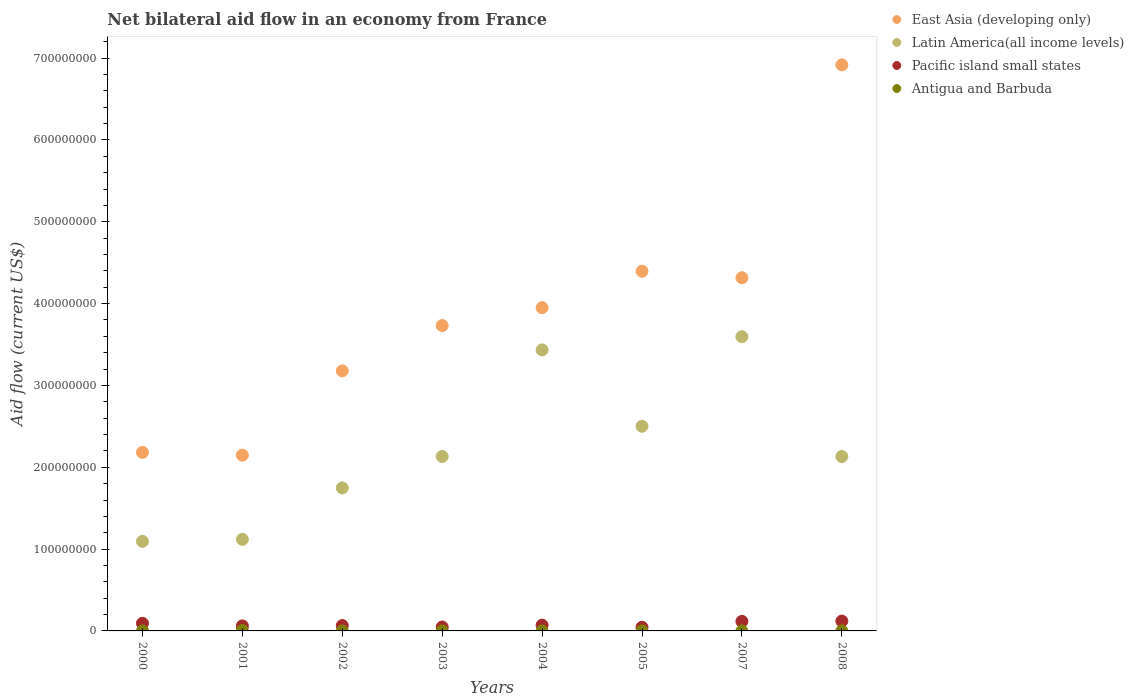Is the number of dotlines equal to the number of legend labels?
Offer a terse response. Yes. What is the net bilateral aid flow in Latin America(all income levels) in 2005?
Give a very brief answer. 2.50e+08. Across all years, what is the maximum net bilateral aid flow in East Asia (developing only)?
Offer a terse response. 6.92e+08. Across all years, what is the minimum net bilateral aid flow in Pacific island small states?
Provide a short and direct response. 4.45e+06. What is the total net bilateral aid flow in Antigua and Barbuda in the graph?
Your response must be concise. 7.00e+05. What is the difference between the net bilateral aid flow in Pacific island small states in 2001 and that in 2007?
Offer a terse response. -5.50e+06. What is the difference between the net bilateral aid flow in Pacific island small states in 2008 and the net bilateral aid flow in East Asia (developing only) in 2007?
Ensure brevity in your answer.  -4.20e+08. What is the average net bilateral aid flow in East Asia (developing only) per year?
Ensure brevity in your answer.  3.85e+08. In the year 2007, what is the difference between the net bilateral aid flow in Latin America(all income levels) and net bilateral aid flow in Antigua and Barbuda?
Provide a succinct answer. 3.60e+08. What is the ratio of the net bilateral aid flow in Pacific island small states in 2002 to that in 2008?
Provide a short and direct response. 0.54. What is the difference between the highest and the second highest net bilateral aid flow in Antigua and Barbuda?
Make the answer very short. 5.50e+05. What is the difference between the highest and the lowest net bilateral aid flow in Pacific island small states?
Provide a short and direct response. 7.58e+06. Is it the case that in every year, the sum of the net bilateral aid flow in Pacific island small states and net bilateral aid flow in Latin America(all income levels)  is greater than the sum of net bilateral aid flow in East Asia (developing only) and net bilateral aid flow in Antigua and Barbuda?
Keep it short and to the point. Yes. Is it the case that in every year, the sum of the net bilateral aid flow in Pacific island small states and net bilateral aid flow in East Asia (developing only)  is greater than the net bilateral aid flow in Latin America(all income levels)?
Offer a very short reply. Yes. Is the net bilateral aid flow in Antigua and Barbuda strictly greater than the net bilateral aid flow in Latin America(all income levels) over the years?
Keep it short and to the point. No. Is the net bilateral aid flow in Latin America(all income levels) strictly less than the net bilateral aid flow in East Asia (developing only) over the years?
Your answer should be very brief. Yes. What is the difference between two consecutive major ticks on the Y-axis?
Provide a short and direct response. 1.00e+08. Are the values on the major ticks of Y-axis written in scientific E-notation?
Ensure brevity in your answer.  No. Does the graph contain any zero values?
Provide a succinct answer. No. Where does the legend appear in the graph?
Your response must be concise. Top right. How are the legend labels stacked?
Your answer should be compact. Vertical. What is the title of the graph?
Give a very brief answer. Net bilateral aid flow in an economy from France. What is the Aid flow (current US$) in East Asia (developing only) in 2000?
Keep it short and to the point. 2.18e+08. What is the Aid flow (current US$) in Latin America(all income levels) in 2000?
Your answer should be very brief. 1.09e+08. What is the Aid flow (current US$) of Pacific island small states in 2000?
Your answer should be compact. 9.29e+06. What is the Aid flow (current US$) of East Asia (developing only) in 2001?
Provide a short and direct response. 2.15e+08. What is the Aid flow (current US$) in Latin America(all income levels) in 2001?
Your response must be concise. 1.12e+08. What is the Aid flow (current US$) in Pacific island small states in 2001?
Provide a succinct answer. 6.15e+06. What is the Aid flow (current US$) in Antigua and Barbuda in 2001?
Ensure brevity in your answer.  5.80e+05. What is the Aid flow (current US$) of East Asia (developing only) in 2002?
Give a very brief answer. 3.18e+08. What is the Aid flow (current US$) of Latin America(all income levels) in 2002?
Provide a succinct answer. 1.75e+08. What is the Aid flow (current US$) in Pacific island small states in 2002?
Provide a short and direct response. 6.55e+06. What is the Aid flow (current US$) of East Asia (developing only) in 2003?
Your answer should be compact. 3.73e+08. What is the Aid flow (current US$) of Latin America(all income levels) in 2003?
Your answer should be very brief. 2.13e+08. What is the Aid flow (current US$) of Pacific island small states in 2003?
Make the answer very short. 4.81e+06. What is the Aid flow (current US$) in Antigua and Barbuda in 2003?
Provide a short and direct response. 10000. What is the Aid flow (current US$) in East Asia (developing only) in 2004?
Offer a very short reply. 3.95e+08. What is the Aid flow (current US$) of Latin America(all income levels) in 2004?
Your answer should be very brief. 3.43e+08. What is the Aid flow (current US$) in Pacific island small states in 2004?
Ensure brevity in your answer.  7.02e+06. What is the Aid flow (current US$) of Antigua and Barbuda in 2004?
Keep it short and to the point. 2.00e+04. What is the Aid flow (current US$) of East Asia (developing only) in 2005?
Offer a very short reply. 4.40e+08. What is the Aid flow (current US$) of Latin America(all income levels) in 2005?
Offer a very short reply. 2.50e+08. What is the Aid flow (current US$) in Pacific island small states in 2005?
Ensure brevity in your answer.  4.45e+06. What is the Aid flow (current US$) of Antigua and Barbuda in 2005?
Make the answer very short. 3.00e+04. What is the Aid flow (current US$) in East Asia (developing only) in 2007?
Your answer should be compact. 4.32e+08. What is the Aid flow (current US$) in Latin America(all income levels) in 2007?
Keep it short and to the point. 3.60e+08. What is the Aid flow (current US$) in Pacific island small states in 2007?
Offer a terse response. 1.16e+07. What is the Aid flow (current US$) of Antigua and Barbuda in 2007?
Provide a succinct answer. 2.00e+04. What is the Aid flow (current US$) of East Asia (developing only) in 2008?
Provide a succinct answer. 6.92e+08. What is the Aid flow (current US$) of Latin America(all income levels) in 2008?
Keep it short and to the point. 2.13e+08. What is the Aid flow (current US$) in Pacific island small states in 2008?
Provide a short and direct response. 1.20e+07. Across all years, what is the maximum Aid flow (current US$) in East Asia (developing only)?
Your response must be concise. 6.92e+08. Across all years, what is the maximum Aid flow (current US$) of Latin America(all income levels)?
Ensure brevity in your answer.  3.60e+08. Across all years, what is the maximum Aid flow (current US$) in Pacific island small states?
Your answer should be compact. 1.20e+07. Across all years, what is the maximum Aid flow (current US$) of Antigua and Barbuda?
Ensure brevity in your answer.  5.80e+05. Across all years, what is the minimum Aid flow (current US$) in East Asia (developing only)?
Keep it short and to the point. 2.15e+08. Across all years, what is the minimum Aid flow (current US$) of Latin America(all income levels)?
Provide a short and direct response. 1.09e+08. Across all years, what is the minimum Aid flow (current US$) of Pacific island small states?
Ensure brevity in your answer.  4.45e+06. What is the total Aid flow (current US$) in East Asia (developing only) in the graph?
Your answer should be very brief. 3.08e+09. What is the total Aid flow (current US$) of Latin America(all income levels) in the graph?
Provide a succinct answer. 1.78e+09. What is the total Aid flow (current US$) of Pacific island small states in the graph?
Provide a succinct answer. 6.20e+07. What is the total Aid flow (current US$) of Antigua and Barbuda in the graph?
Offer a very short reply. 7.00e+05. What is the difference between the Aid flow (current US$) in East Asia (developing only) in 2000 and that in 2001?
Your answer should be compact. 3.42e+06. What is the difference between the Aid flow (current US$) of Latin America(all income levels) in 2000 and that in 2001?
Provide a succinct answer. -2.40e+06. What is the difference between the Aid flow (current US$) in Pacific island small states in 2000 and that in 2001?
Give a very brief answer. 3.14e+06. What is the difference between the Aid flow (current US$) of Antigua and Barbuda in 2000 and that in 2001?
Provide a succinct answer. -5.70e+05. What is the difference between the Aid flow (current US$) in East Asia (developing only) in 2000 and that in 2002?
Keep it short and to the point. -9.96e+07. What is the difference between the Aid flow (current US$) in Latin America(all income levels) in 2000 and that in 2002?
Your answer should be compact. -6.53e+07. What is the difference between the Aid flow (current US$) in Pacific island small states in 2000 and that in 2002?
Provide a succinct answer. 2.74e+06. What is the difference between the Aid flow (current US$) of East Asia (developing only) in 2000 and that in 2003?
Your answer should be compact. -1.55e+08. What is the difference between the Aid flow (current US$) of Latin America(all income levels) in 2000 and that in 2003?
Offer a very short reply. -1.04e+08. What is the difference between the Aid flow (current US$) of Pacific island small states in 2000 and that in 2003?
Offer a terse response. 4.48e+06. What is the difference between the Aid flow (current US$) of East Asia (developing only) in 2000 and that in 2004?
Keep it short and to the point. -1.77e+08. What is the difference between the Aid flow (current US$) in Latin America(all income levels) in 2000 and that in 2004?
Offer a very short reply. -2.34e+08. What is the difference between the Aid flow (current US$) in Pacific island small states in 2000 and that in 2004?
Make the answer very short. 2.27e+06. What is the difference between the Aid flow (current US$) in Antigua and Barbuda in 2000 and that in 2004?
Keep it short and to the point. -10000. What is the difference between the Aid flow (current US$) of East Asia (developing only) in 2000 and that in 2005?
Your answer should be very brief. -2.21e+08. What is the difference between the Aid flow (current US$) in Latin America(all income levels) in 2000 and that in 2005?
Offer a very short reply. -1.41e+08. What is the difference between the Aid flow (current US$) in Pacific island small states in 2000 and that in 2005?
Your answer should be very brief. 4.84e+06. What is the difference between the Aid flow (current US$) in Antigua and Barbuda in 2000 and that in 2005?
Make the answer very short. -2.00e+04. What is the difference between the Aid flow (current US$) of East Asia (developing only) in 2000 and that in 2007?
Provide a short and direct response. -2.13e+08. What is the difference between the Aid flow (current US$) in Latin America(all income levels) in 2000 and that in 2007?
Give a very brief answer. -2.50e+08. What is the difference between the Aid flow (current US$) in Pacific island small states in 2000 and that in 2007?
Your response must be concise. -2.36e+06. What is the difference between the Aid flow (current US$) of Antigua and Barbuda in 2000 and that in 2007?
Make the answer very short. -10000. What is the difference between the Aid flow (current US$) of East Asia (developing only) in 2000 and that in 2008?
Your response must be concise. -4.74e+08. What is the difference between the Aid flow (current US$) of Latin America(all income levels) in 2000 and that in 2008?
Provide a succinct answer. -1.04e+08. What is the difference between the Aid flow (current US$) in Pacific island small states in 2000 and that in 2008?
Ensure brevity in your answer.  -2.74e+06. What is the difference between the Aid flow (current US$) in Antigua and Barbuda in 2000 and that in 2008?
Make the answer very short. 0. What is the difference between the Aid flow (current US$) in East Asia (developing only) in 2001 and that in 2002?
Keep it short and to the point. -1.03e+08. What is the difference between the Aid flow (current US$) of Latin America(all income levels) in 2001 and that in 2002?
Ensure brevity in your answer.  -6.29e+07. What is the difference between the Aid flow (current US$) of Pacific island small states in 2001 and that in 2002?
Ensure brevity in your answer.  -4.00e+05. What is the difference between the Aid flow (current US$) of Antigua and Barbuda in 2001 and that in 2002?
Offer a terse response. 5.60e+05. What is the difference between the Aid flow (current US$) in East Asia (developing only) in 2001 and that in 2003?
Ensure brevity in your answer.  -1.58e+08. What is the difference between the Aid flow (current US$) of Latin America(all income levels) in 2001 and that in 2003?
Offer a terse response. -1.01e+08. What is the difference between the Aid flow (current US$) in Pacific island small states in 2001 and that in 2003?
Provide a short and direct response. 1.34e+06. What is the difference between the Aid flow (current US$) in Antigua and Barbuda in 2001 and that in 2003?
Make the answer very short. 5.70e+05. What is the difference between the Aid flow (current US$) in East Asia (developing only) in 2001 and that in 2004?
Give a very brief answer. -1.80e+08. What is the difference between the Aid flow (current US$) in Latin America(all income levels) in 2001 and that in 2004?
Offer a terse response. -2.32e+08. What is the difference between the Aid flow (current US$) in Pacific island small states in 2001 and that in 2004?
Keep it short and to the point. -8.70e+05. What is the difference between the Aid flow (current US$) of Antigua and Barbuda in 2001 and that in 2004?
Your answer should be very brief. 5.60e+05. What is the difference between the Aid flow (current US$) in East Asia (developing only) in 2001 and that in 2005?
Provide a short and direct response. -2.25e+08. What is the difference between the Aid flow (current US$) of Latin America(all income levels) in 2001 and that in 2005?
Provide a succinct answer. -1.38e+08. What is the difference between the Aid flow (current US$) of Pacific island small states in 2001 and that in 2005?
Your answer should be very brief. 1.70e+06. What is the difference between the Aid flow (current US$) of East Asia (developing only) in 2001 and that in 2007?
Make the answer very short. -2.17e+08. What is the difference between the Aid flow (current US$) in Latin America(all income levels) in 2001 and that in 2007?
Offer a very short reply. -2.48e+08. What is the difference between the Aid flow (current US$) in Pacific island small states in 2001 and that in 2007?
Provide a succinct answer. -5.50e+06. What is the difference between the Aid flow (current US$) of Antigua and Barbuda in 2001 and that in 2007?
Make the answer very short. 5.60e+05. What is the difference between the Aid flow (current US$) in East Asia (developing only) in 2001 and that in 2008?
Provide a short and direct response. -4.77e+08. What is the difference between the Aid flow (current US$) in Latin America(all income levels) in 2001 and that in 2008?
Offer a terse response. -1.01e+08. What is the difference between the Aid flow (current US$) of Pacific island small states in 2001 and that in 2008?
Give a very brief answer. -5.88e+06. What is the difference between the Aid flow (current US$) of Antigua and Barbuda in 2001 and that in 2008?
Provide a short and direct response. 5.70e+05. What is the difference between the Aid flow (current US$) of East Asia (developing only) in 2002 and that in 2003?
Offer a very short reply. -5.54e+07. What is the difference between the Aid flow (current US$) of Latin America(all income levels) in 2002 and that in 2003?
Provide a short and direct response. -3.85e+07. What is the difference between the Aid flow (current US$) of Pacific island small states in 2002 and that in 2003?
Your response must be concise. 1.74e+06. What is the difference between the Aid flow (current US$) in Antigua and Barbuda in 2002 and that in 2003?
Provide a short and direct response. 10000. What is the difference between the Aid flow (current US$) in East Asia (developing only) in 2002 and that in 2004?
Make the answer very short. -7.72e+07. What is the difference between the Aid flow (current US$) in Latin America(all income levels) in 2002 and that in 2004?
Offer a terse response. -1.69e+08. What is the difference between the Aid flow (current US$) of Pacific island small states in 2002 and that in 2004?
Offer a very short reply. -4.70e+05. What is the difference between the Aid flow (current US$) of East Asia (developing only) in 2002 and that in 2005?
Provide a succinct answer. -1.22e+08. What is the difference between the Aid flow (current US$) in Latin America(all income levels) in 2002 and that in 2005?
Offer a terse response. -7.54e+07. What is the difference between the Aid flow (current US$) of Pacific island small states in 2002 and that in 2005?
Offer a terse response. 2.10e+06. What is the difference between the Aid flow (current US$) in Antigua and Barbuda in 2002 and that in 2005?
Provide a short and direct response. -10000. What is the difference between the Aid flow (current US$) of East Asia (developing only) in 2002 and that in 2007?
Your answer should be compact. -1.14e+08. What is the difference between the Aid flow (current US$) of Latin America(all income levels) in 2002 and that in 2007?
Offer a very short reply. -1.85e+08. What is the difference between the Aid flow (current US$) of Pacific island small states in 2002 and that in 2007?
Offer a terse response. -5.10e+06. What is the difference between the Aid flow (current US$) in Antigua and Barbuda in 2002 and that in 2007?
Offer a terse response. 0. What is the difference between the Aid flow (current US$) of East Asia (developing only) in 2002 and that in 2008?
Make the answer very short. -3.74e+08. What is the difference between the Aid flow (current US$) in Latin America(all income levels) in 2002 and that in 2008?
Make the answer very short. -3.84e+07. What is the difference between the Aid flow (current US$) of Pacific island small states in 2002 and that in 2008?
Your answer should be compact. -5.48e+06. What is the difference between the Aid flow (current US$) in East Asia (developing only) in 2003 and that in 2004?
Your response must be concise. -2.18e+07. What is the difference between the Aid flow (current US$) of Latin America(all income levels) in 2003 and that in 2004?
Give a very brief answer. -1.30e+08. What is the difference between the Aid flow (current US$) of Pacific island small states in 2003 and that in 2004?
Make the answer very short. -2.21e+06. What is the difference between the Aid flow (current US$) of East Asia (developing only) in 2003 and that in 2005?
Your answer should be compact. -6.64e+07. What is the difference between the Aid flow (current US$) in Latin America(all income levels) in 2003 and that in 2005?
Offer a very short reply. -3.69e+07. What is the difference between the Aid flow (current US$) in Pacific island small states in 2003 and that in 2005?
Your answer should be very brief. 3.60e+05. What is the difference between the Aid flow (current US$) of Antigua and Barbuda in 2003 and that in 2005?
Offer a very short reply. -2.00e+04. What is the difference between the Aid flow (current US$) of East Asia (developing only) in 2003 and that in 2007?
Provide a succinct answer. -5.84e+07. What is the difference between the Aid flow (current US$) of Latin America(all income levels) in 2003 and that in 2007?
Make the answer very short. -1.46e+08. What is the difference between the Aid flow (current US$) in Pacific island small states in 2003 and that in 2007?
Keep it short and to the point. -6.84e+06. What is the difference between the Aid flow (current US$) of East Asia (developing only) in 2003 and that in 2008?
Offer a terse response. -3.19e+08. What is the difference between the Aid flow (current US$) in Pacific island small states in 2003 and that in 2008?
Your response must be concise. -7.22e+06. What is the difference between the Aid flow (current US$) in East Asia (developing only) in 2004 and that in 2005?
Give a very brief answer. -4.46e+07. What is the difference between the Aid flow (current US$) of Latin America(all income levels) in 2004 and that in 2005?
Make the answer very short. 9.33e+07. What is the difference between the Aid flow (current US$) of Pacific island small states in 2004 and that in 2005?
Your answer should be very brief. 2.57e+06. What is the difference between the Aid flow (current US$) of East Asia (developing only) in 2004 and that in 2007?
Your answer should be very brief. -3.66e+07. What is the difference between the Aid flow (current US$) in Latin America(all income levels) in 2004 and that in 2007?
Provide a short and direct response. -1.62e+07. What is the difference between the Aid flow (current US$) of Pacific island small states in 2004 and that in 2007?
Give a very brief answer. -4.63e+06. What is the difference between the Aid flow (current US$) of Antigua and Barbuda in 2004 and that in 2007?
Make the answer very short. 0. What is the difference between the Aid flow (current US$) in East Asia (developing only) in 2004 and that in 2008?
Provide a succinct answer. -2.97e+08. What is the difference between the Aid flow (current US$) in Latin America(all income levels) in 2004 and that in 2008?
Make the answer very short. 1.30e+08. What is the difference between the Aid flow (current US$) in Pacific island small states in 2004 and that in 2008?
Give a very brief answer. -5.01e+06. What is the difference between the Aid flow (current US$) in Antigua and Barbuda in 2004 and that in 2008?
Provide a short and direct response. 10000. What is the difference between the Aid flow (current US$) in East Asia (developing only) in 2005 and that in 2007?
Give a very brief answer. 7.94e+06. What is the difference between the Aid flow (current US$) of Latin America(all income levels) in 2005 and that in 2007?
Your response must be concise. -1.09e+08. What is the difference between the Aid flow (current US$) in Pacific island small states in 2005 and that in 2007?
Your answer should be compact. -7.20e+06. What is the difference between the Aid flow (current US$) of Antigua and Barbuda in 2005 and that in 2007?
Give a very brief answer. 10000. What is the difference between the Aid flow (current US$) of East Asia (developing only) in 2005 and that in 2008?
Make the answer very short. -2.52e+08. What is the difference between the Aid flow (current US$) in Latin America(all income levels) in 2005 and that in 2008?
Provide a succinct answer. 3.70e+07. What is the difference between the Aid flow (current US$) in Pacific island small states in 2005 and that in 2008?
Your response must be concise. -7.58e+06. What is the difference between the Aid flow (current US$) in Antigua and Barbuda in 2005 and that in 2008?
Give a very brief answer. 2.00e+04. What is the difference between the Aid flow (current US$) in East Asia (developing only) in 2007 and that in 2008?
Offer a very short reply. -2.60e+08. What is the difference between the Aid flow (current US$) in Latin America(all income levels) in 2007 and that in 2008?
Ensure brevity in your answer.  1.46e+08. What is the difference between the Aid flow (current US$) of Pacific island small states in 2007 and that in 2008?
Ensure brevity in your answer.  -3.80e+05. What is the difference between the Aid flow (current US$) in East Asia (developing only) in 2000 and the Aid flow (current US$) in Latin America(all income levels) in 2001?
Give a very brief answer. 1.06e+08. What is the difference between the Aid flow (current US$) of East Asia (developing only) in 2000 and the Aid flow (current US$) of Pacific island small states in 2001?
Provide a succinct answer. 2.12e+08. What is the difference between the Aid flow (current US$) in East Asia (developing only) in 2000 and the Aid flow (current US$) in Antigua and Barbuda in 2001?
Make the answer very short. 2.18e+08. What is the difference between the Aid flow (current US$) of Latin America(all income levels) in 2000 and the Aid flow (current US$) of Pacific island small states in 2001?
Your answer should be very brief. 1.03e+08. What is the difference between the Aid flow (current US$) of Latin America(all income levels) in 2000 and the Aid flow (current US$) of Antigua and Barbuda in 2001?
Provide a short and direct response. 1.09e+08. What is the difference between the Aid flow (current US$) of Pacific island small states in 2000 and the Aid flow (current US$) of Antigua and Barbuda in 2001?
Your response must be concise. 8.71e+06. What is the difference between the Aid flow (current US$) in East Asia (developing only) in 2000 and the Aid flow (current US$) in Latin America(all income levels) in 2002?
Offer a very short reply. 4.35e+07. What is the difference between the Aid flow (current US$) of East Asia (developing only) in 2000 and the Aid flow (current US$) of Pacific island small states in 2002?
Your answer should be compact. 2.12e+08. What is the difference between the Aid flow (current US$) in East Asia (developing only) in 2000 and the Aid flow (current US$) in Antigua and Barbuda in 2002?
Offer a very short reply. 2.18e+08. What is the difference between the Aid flow (current US$) of Latin America(all income levels) in 2000 and the Aid flow (current US$) of Pacific island small states in 2002?
Provide a short and direct response. 1.03e+08. What is the difference between the Aid flow (current US$) of Latin America(all income levels) in 2000 and the Aid flow (current US$) of Antigua and Barbuda in 2002?
Your response must be concise. 1.09e+08. What is the difference between the Aid flow (current US$) in Pacific island small states in 2000 and the Aid flow (current US$) in Antigua and Barbuda in 2002?
Provide a short and direct response. 9.27e+06. What is the difference between the Aid flow (current US$) of East Asia (developing only) in 2000 and the Aid flow (current US$) of Latin America(all income levels) in 2003?
Provide a succinct answer. 5.00e+06. What is the difference between the Aid flow (current US$) in East Asia (developing only) in 2000 and the Aid flow (current US$) in Pacific island small states in 2003?
Keep it short and to the point. 2.13e+08. What is the difference between the Aid flow (current US$) in East Asia (developing only) in 2000 and the Aid flow (current US$) in Antigua and Barbuda in 2003?
Provide a short and direct response. 2.18e+08. What is the difference between the Aid flow (current US$) in Latin America(all income levels) in 2000 and the Aid flow (current US$) in Pacific island small states in 2003?
Your answer should be compact. 1.05e+08. What is the difference between the Aid flow (current US$) in Latin America(all income levels) in 2000 and the Aid flow (current US$) in Antigua and Barbuda in 2003?
Offer a terse response. 1.09e+08. What is the difference between the Aid flow (current US$) of Pacific island small states in 2000 and the Aid flow (current US$) of Antigua and Barbuda in 2003?
Your answer should be compact. 9.28e+06. What is the difference between the Aid flow (current US$) of East Asia (developing only) in 2000 and the Aid flow (current US$) of Latin America(all income levels) in 2004?
Provide a succinct answer. -1.25e+08. What is the difference between the Aid flow (current US$) of East Asia (developing only) in 2000 and the Aid flow (current US$) of Pacific island small states in 2004?
Your response must be concise. 2.11e+08. What is the difference between the Aid flow (current US$) in East Asia (developing only) in 2000 and the Aid flow (current US$) in Antigua and Barbuda in 2004?
Keep it short and to the point. 2.18e+08. What is the difference between the Aid flow (current US$) in Latin America(all income levels) in 2000 and the Aid flow (current US$) in Pacific island small states in 2004?
Keep it short and to the point. 1.02e+08. What is the difference between the Aid flow (current US$) of Latin America(all income levels) in 2000 and the Aid flow (current US$) of Antigua and Barbuda in 2004?
Ensure brevity in your answer.  1.09e+08. What is the difference between the Aid flow (current US$) of Pacific island small states in 2000 and the Aid flow (current US$) of Antigua and Barbuda in 2004?
Give a very brief answer. 9.27e+06. What is the difference between the Aid flow (current US$) in East Asia (developing only) in 2000 and the Aid flow (current US$) in Latin America(all income levels) in 2005?
Your answer should be compact. -3.19e+07. What is the difference between the Aid flow (current US$) of East Asia (developing only) in 2000 and the Aid flow (current US$) of Pacific island small states in 2005?
Offer a terse response. 2.14e+08. What is the difference between the Aid flow (current US$) in East Asia (developing only) in 2000 and the Aid flow (current US$) in Antigua and Barbuda in 2005?
Provide a short and direct response. 2.18e+08. What is the difference between the Aid flow (current US$) of Latin America(all income levels) in 2000 and the Aid flow (current US$) of Pacific island small states in 2005?
Your answer should be very brief. 1.05e+08. What is the difference between the Aid flow (current US$) of Latin America(all income levels) in 2000 and the Aid flow (current US$) of Antigua and Barbuda in 2005?
Offer a terse response. 1.09e+08. What is the difference between the Aid flow (current US$) of Pacific island small states in 2000 and the Aid flow (current US$) of Antigua and Barbuda in 2005?
Your answer should be compact. 9.26e+06. What is the difference between the Aid flow (current US$) of East Asia (developing only) in 2000 and the Aid flow (current US$) of Latin America(all income levels) in 2007?
Your answer should be compact. -1.41e+08. What is the difference between the Aid flow (current US$) of East Asia (developing only) in 2000 and the Aid flow (current US$) of Pacific island small states in 2007?
Your answer should be compact. 2.07e+08. What is the difference between the Aid flow (current US$) of East Asia (developing only) in 2000 and the Aid flow (current US$) of Antigua and Barbuda in 2007?
Ensure brevity in your answer.  2.18e+08. What is the difference between the Aid flow (current US$) of Latin America(all income levels) in 2000 and the Aid flow (current US$) of Pacific island small states in 2007?
Your answer should be very brief. 9.78e+07. What is the difference between the Aid flow (current US$) of Latin America(all income levels) in 2000 and the Aid flow (current US$) of Antigua and Barbuda in 2007?
Your answer should be very brief. 1.09e+08. What is the difference between the Aid flow (current US$) of Pacific island small states in 2000 and the Aid flow (current US$) of Antigua and Barbuda in 2007?
Provide a succinct answer. 9.27e+06. What is the difference between the Aid flow (current US$) in East Asia (developing only) in 2000 and the Aid flow (current US$) in Latin America(all income levels) in 2008?
Your response must be concise. 5.04e+06. What is the difference between the Aid flow (current US$) of East Asia (developing only) in 2000 and the Aid flow (current US$) of Pacific island small states in 2008?
Make the answer very short. 2.06e+08. What is the difference between the Aid flow (current US$) in East Asia (developing only) in 2000 and the Aid flow (current US$) in Antigua and Barbuda in 2008?
Make the answer very short. 2.18e+08. What is the difference between the Aid flow (current US$) of Latin America(all income levels) in 2000 and the Aid flow (current US$) of Pacific island small states in 2008?
Your response must be concise. 9.74e+07. What is the difference between the Aid flow (current US$) of Latin America(all income levels) in 2000 and the Aid flow (current US$) of Antigua and Barbuda in 2008?
Provide a short and direct response. 1.09e+08. What is the difference between the Aid flow (current US$) of Pacific island small states in 2000 and the Aid flow (current US$) of Antigua and Barbuda in 2008?
Your answer should be very brief. 9.28e+06. What is the difference between the Aid flow (current US$) in East Asia (developing only) in 2001 and the Aid flow (current US$) in Latin America(all income levels) in 2002?
Ensure brevity in your answer.  4.00e+07. What is the difference between the Aid flow (current US$) of East Asia (developing only) in 2001 and the Aid flow (current US$) of Pacific island small states in 2002?
Offer a very short reply. 2.08e+08. What is the difference between the Aid flow (current US$) of East Asia (developing only) in 2001 and the Aid flow (current US$) of Antigua and Barbuda in 2002?
Offer a terse response. 2.15e+08. What is the difference between the Aid flow (current US$) of Latin America(all income levels) in 2001 and the Aid flow (current US$) of Pacific island small states in 2002?
Offer a terse response. 1.05e+08. What is the difference between the Aid flow (current US$) of Latin America(all income levels) in 2001 and the Aid flow (current US$) of Antigua and Barbuda in 2002?
Provide a succinct answer. 1.12e+08. What is the difference between the Aid flow (current US$) of Pacific island small states in 2001 and the Aid flow (current US$) of Antigua and Barbuda in 2002?
Your answer should be compact. 6.13e+06. What is the difference between the Aid flow (current US$) of East Asia (developing only) in 2001 and the Aid flow (current US$) of Latin America(all income levels) in 2003?
Keep it short and to the point. 1.58e+06. What is the difference between the Aid flow (current US$) of East Asia (developing only) in 2001 and the Aid flow (current US$) of Pacific island small states in 2003?
Make the answer very short. 2.10e+08. What is the difference between the Aid flow (current US$) in East Asia (developing only) in 2001 and the Aid flow (current US$) in Antigua and Barbuda in 2003?
Your answer should be very brief. 2.15e+08. What is the difference between the Aid flow (current US$) of Latin America(all income levels) in 2001 and the Aid flow (current US$) of Pacific island small states in 2003?
Provide a short and direct response. 1.07e+08. What is the difference between the Aid flow (current US$) in Latin America(all income levels) in 2001 and the Aid flow (current US$) in Antigua and Barbuda in 2003?
Offer a very short reply. 1.12e+08. What is the difference between the Aid flow (current US$) in Pacific island small states in 2001 and the Aid flow (current US$) in Antigua and Barbuda in 2003?
Provide a succinct answer. 6.14e+06. What is the difference between the Aid flow (current US$) in East Asia (developing only) in 2001 and the Aid flow (current US$) in Latin America(all income levels) in 2004?
Offer a very short reply. -1.29e+08. What is the difference between the Aid flow (current US$) of East Asia (developing only) in 2001 and the Aid flow (current US$) of Pacific island small states in 2004?
Offer a terse response. 2.08e+08. What is the difference between the Aid flow (current US$) in East Asia (developing only) in 2001 and the Aid flow (current US$) in Antigua and Barbuda in 2004?
Provide a short and direct response. 2.15e+08. What is the difference between the Aid flow (current US$) of Latin America(all income levels) in 2001 and the Aid flow (current US$) of Pacific island small states in 2004?
Provide a short and direct response. 1.05e+08. What is the difference between the Aid flow (current US$) of Latin America(all income levels) in 2001 and the Aid flow (current US$) of Antigua and Barbuda in 2004?
Provide a short and direct response. 1.12e+08. What is the difference between the Aid flow (current US$) in Pacific island small states in 2001 and the Aid flow (current US$) in Antigua and Barbuda in 2004?
Your answer should be compact. 6.13e+06. What is the difference between the Aid flow (current US$) of East Asia (developing only) in 2001 and the Aid flow (current US$) of Latin America(all income levels) in 2005?
Keep it short and to the point. -3.53e+07. What is the difference between the Aid flow (current US$) of East Asia (developing only) in 2001 and the Aid flow (current US$) of Pacific island small states in 2005?
Your answer should be compact. 2.10e+08. What is the difference between the Aid flow (current US$) of East Asia (developing only) in 2001 and the Aid flow (current US$) of Antigua and Barbuda in 2005?
Your answer should be compact. 2.15e+08. What is the difference between the Aid flow (current US$) in Latin America(all income levels) in 2001 and the Aid flow (current US$) in Pacific island small states in 2005?
Provide a succinct answer. 1.07e+08. What is the difference between the Aid flow (current US$) of Latin America(all income levels) in 2001 and the Aid flow (current US$) of Antigua and Barbuda in 2005?
Make the answer very short. 1.12e+08. What is the difference between the Aid flow (current US$) in Pacific island small states in 2001 and the Aid flow (current US$) in Antigua and Barbuda in 2005?
Offer a terse response. 6.12e+06. What is the difference between the Aid flow (current US$) in East Asia (developing only) in 2001 and the Aid flow (current US$) in Latin America(all income levels) in 2007?
Keep it short and to the point. -1.45e+08. What is the difference between the Aid flow (current US$) in East Asia (developing only) in 2001 and the Aid flow (current US$) in Pacific island small states in 2007?
Make the answer very short. 2.03e+08. What is the difference between the Aid flow (current US$) of East Asia (developing only) in 2001 and the Aid flow (current US$) of Antigua and Barbuda in 2007?
Your response must be concise. 2.15e+08. What is the difference between the Aid flow (current US$) of Latin America(all income levels) in 2001 and the Aid flow (current US$) of Pacific island small states in 2007?
Your response must be concise. 1.00e+08. What is the difference between the Aid flow (current US$) in Latin America(all income levels) in 2001 and the Aid flow (current US$) in Antigua and Barbuda in 2007?
Offer a terse response. 1.12e+08. What is the difference between the Aid flow (current US$) in Pacific island small states in 2001 and the Aid flow (current US$) in Antigua and Barbuda in 2007?
Ensure brevity in your answer.  6.13e+06. What is the difference between the Aid flow (current US$) of East Asia (developing only) in 2001 and the Aid flow (current US$) of Latin America(all income levels) in 2008?
Make the answer very short. 1.62e+06. What is the difference between the Aid flow (current US$) of East Asia (developing only) in 2001 and the Aid flow (current US$) of Pacific island small states in 2008?
Your answer should be very brief. 2.03e+08. What is the difference between the Aid flow (current US$) of East Asia (developing only) in 2001 and the Aid flow (current US$) of Antigua and Barbuda in 2008?
Your answer should be very brief. 2.15e+08. What is the difference between the Aid flow (current US$) in Latin America(all income levels) in 2001 and the Aid flow (current US$) in Pacific island small states in 2008?
Make the answer very short. 9.98e+07. What is the difference between the Aid flow (current US$) in Latin America(all income levels) in 2001 and the Aid flow (current US$) in Antigua and Barbuda in 2008?
Your answer should be compact. 1.12e+08. What is the difference between the Aid flow (current US$) of Pacific island small states in 2001 and the Aid flow (current US$) of Antigua and Barbuda in 2008?
Your answer should be compact. 6.14e+06. What is the difference between the Aid flow (current US$) in East Asia (developing only) in 2002 and the Aid flow (current US$) in Latin America(all income levels) in 2003?
Make the answer very short. 1.05e+08. What is the difference between the Aid flow (current US$) of East Asia (developing only) in 2002 and the Aid flow (current US$) of Pacific island small states in 2003?
Keep it short and to the point. 3.13e+08. What is the difference between the Aid flow (current US$) of East Asia (developing only) in 2002 and the Aid flow (current US$) of Antigua and Barbuda in 2003?
Provide a succinct answer. 3.18e+08. What is the difference between the Aid flow (current US$) of Latin America(all income levels) in 2002 and the Aid flow (current US$) of Pacific island small states in 2003?
Keep it short and to the point. 1.70e+08. What is the difference between the Aid flow (current US$) in Latin America(all income levels) in 2002 and the Aid flow (current US$) in Antigua and Barbuda in 2003?
Your response must be concise. 1.75e+08. What is the difference between the Aid flow (current US$) of Pacific island small states in 2002 and the Aid flow (current US$) of Antigua and Barbuda in 2003?
Your answer should be very brief. 6.54e+06. What is the difference between the Aid flow (current US$) of East Asia (developing only) in 2002 and the Aid flow (current US$) of Latin America(all income levels) in 2004?
Offer a terse response. -2.56e+07. What is the difference between the Aid flow (current US$) of East Asia (developing only) in 2002 and the Aid flow (current US$) of Pacific island small states in 2004?
Your answer should be very brief. 3.11e+08. What is the difference between the Aid flow (current US$) in East Asia (developing only) in 2002 and the Aid flow (current US$) in Antigua and Barbuda in 2004?
Keep it short and to the point. 3.18e+08. What is the difference between the Aid flow (current US$) in Latin America(all income levels) in 2002 and the Aid flow (current US$) in Pacific island small states in 2004?
Provide a short and direct response. 1.68e+08. What is the difference between the Aid flow (current US$) in Latin America(all income levels) in 2002 and the Aid flow (current US$) in Antigua and Barbuda in 2004?
Your response must be concise. 1.75e+08. What is the difference between the Aid flow (current US$) in Pacific island small states in 2002 and the Aid flow (current US$) in Antigua and Barbuda in 2004?
Give a very brief answer. 6.53e+06. What is the difference between the Aid flow (current US$) in East Asia (developing only) in 2002 and the Aid flow (current US$) in Latin America(all income levels) in 2005?
Ensure brevity in your answer.  6.77e+07. What is the difference between the Aid flow (current US$) in East Asia (developing only) in 2002 and the Aid flow (current US$) in Pacific island small states in 2005?
Provide a short and direct response. 3.13e+08. What is the difference between the Aid flow (current US$) in East Asia (developing only) in 2002 and the Aid flow (current US$) in Antigua and Barbuda in 2005?
Give a very brief answer. 3.18e+08. What is the difference between the Aid flow (current US$) of Latin America(all income levels) in 2002 and the Aid flow (current US$) of Pacific island small states in 2005?
Your answer should be very brief. 1.70e+08. What is the difference between the Aid flow (current US$) of Latin America(all income levels) in 2002 and the Aid flow (current US$) of Antigua and Barbuda in 2005?
Provide a succinct answer. 1.75e+08. What is the difference between the Aid flow (current US$) in Pacific island small states in 2002 and the Aid flow (current US$) in Antigua and Barbuda in 2005?
Offer a terse response. 6.52e+06. What is the difference between the Aid flow (current US$) of East Asia (developing only) in 2002 and the Aid flow (current US$) of Latin America(all income levels) in 2007?
Your response must be concise. -4.17e+07. What is the difference between the Aid flow (current US$) of East Asia (developing only) in 2002 and the Aid flow (current US$) of Pacific island small states in 2007?
Provide a short and direct response. 3.06e+08. What is the difference between the Aid flow (current US$) in East Asia (developing only) in 2002 and the Aid flow (current US$) in Antigua and Barbuda in 2007?
Your response must be concise. 3.18e+08. What is the difference between the Aid flow (current US$) in Latin America(all income levels) in 2002 and the Aid flow (current US$) in Pacific island small states in 2007?
Your answer should be very brief. 1.63e+08. What is the difference between the Aid flow (current US$) in Latin America(all income levels) in 2002 and the Aid flow (current US$) in Antigua and Barbuda in 2007?
Your response must be concise. 1.75e+08. What is the difference between the Aid flow (current US$) of Pacific island small states in 2002 and the Aid flow (current US$) of Antigua and Barbuda in 2007?
Make the answer very short. 6.53e+06. What is the difference between the Aid flow (current US$) of East Asia (developing only) in 2002 and the Aid flow (current US$) of Latin America(all income levels) in 2008?
Your answer should be very brief. 1.05e+08. What is the difference between the Aid flow (current US$) in East Asia (developing only) in 2002 and the Aid flow (current US$) in Pacific island small states in 2008?
Offer a terse response. 3.06e+08. What is the difference between the Aid flow (current US$) of East Asia (developing only) in 2002 and the Aid flow (current US$) of Antigua and Barbuda in 2008?
Offer a terse response. 3.18e+08. What is the difference between the Aid flow (current US$) in Latin America(all income levels) in 2002 and the Aid flow (current US$) in Pacific island small states in 2008?
Ensure brevity in your answer.  1.63e+08. What is the difference between the Aid flow (current US$) of Latin America(all income levels) in 2002 and the Aid flow (current US$) of Antigua and Barbuda in 2008?
Keep it short and to the point. 1.75e+08. What is the difference between the Aid flow (current US$) of Pacific island small states in 2002 and the Aid flow (current US$) of Antigua and Barbuda in 2008?
Your answer should be very brief. 6.54e+06. What is the difference between the Aid flow (current US$) of East Asia (developing only) in 2003 and the Aid flow (current US$) of Latin America(all income levels) in 2004?
Your response must be concise. 2.98e+07. What is the difference between the Aid flow (current US$) in East Asia (developing only) in 2003 and the Aid flow (current US$) in Pacific island small states in 2004?
Your answer should be compact. 3.66e+08. What is the difference between the Aid flow (current US$) of East Asia (developing only) in 2003 and the Aid flow (current US$) of Antigua and Barbuda in 2004?
Your answer should be very brief. 3.73e+08. What is the difference between the Aid flow (current US$) of Latin America(all income levels) in 2003 and the Aid flow (current US$) of Pacific island small states in 2004?
Keep it short and to the point. 2.06e+08. What is the difference between the Aid flow (current US$) in Latin America(all income levels) in 2003 and the Aid flow (current US$) in Antigua and Barbuda in 2004?
Offer a very short reply. 2.13e+08. What is the difference between the Aid flow (current US$) in Pacific island small states in 2003 and the Aid flow (current US$) in Antigua and Barbuda in 2004?
Provide a succinct answer. 4.79e+06. What is the difference between the Aid flow (current US$) in East Asia (developing only) in 2003 and the Aid flow (current US$) in Latin America(all income levels) in 2005?
Give a very brief answer. 1.23e+08. What is the difference between the Aid flow (current US$) of East Asia (developing only) in 2003 and the Aid flow (current US$) of Pacific island small states in 2005?
Provide a short and direct response. 3.69e+08. What is the difference between the Aid flow (current US$) in East Asia (developing only) in 2003 and the Aid flow (current US$) in Antigua and Barbuda in 2005?
Give a very brief answer. 3.73e+08. What is the difference between the Aid flow (current US$) in Latin America(all income levels) in 2003 and the Aid flow (current US$) in Pacific island small states in 2005?
Provide a succinct answer. 2.09e+08. What is the difference between the Aid flow (current US$) in Latin America(all income levels) in 2003 and the Aid flow (current US$) in Antigua and Barbuda in 2005?
Provide a succinct answer. 2.13e+08. What is the difference between the Aid flow (current US$) of Pacific island small states in 2003 and the Aid flow (current US$) of Antigua and Barbuda in 2005?
Your answer should be compact. 4.78e+06. What is the difference between the Aid flow (current US$) of East Asia (developing only) in 2003 and the Aid flow (current US$) of Latin America(all income levels) in 2007?
Keep it short and to the point. 1.37e+07. What is the difference between the Aid flow (current US$) of East Asia (developing only) in 2003 and the Aid flow (current US$) of Pacific island small states in 2007?
Provide a succinct answer. 3.62e+08. What is the difference between the Aid flow (current US$) of East Asia (developing only) in 2003 and the Aid flow (current US$) of Antigua and Barbuda in 2007?
Your answer should be very brief. 3.73e+08. What is the difference between the Aid flow (current US$) in Latin America(all income levels) in 2003 and the Aid flow (current US$) in Pacific island small states in 2007?
Your answer should be compact. 2.02e+08. What is the difference between the Aid flow (current US$) of Latin America(all income levels) in 2003 and the Aid flow (current US$) of Antigua and Barbuda in 2007?
Provide a succinct answer. 2.13e+08. What is the difference between the Aid flow (current US$) in Pacific island small states in 2003 and the Aid flow (current US$) in Antigua and Barbuda in 2007?
Keep it short and to the point. 4.79e+06. What is the difference between the Aid flow (current US$) in East Asia (developing only) in 2003 and the Aid flow (current US$) in Latin America(all income levels) in 2008?
Your answer should be compact. 1.60e+08. What is the difference between the Aid flow (current US$) of East Asia (developing only) in 2003 and the Aid flow (current US$) of Pacific island small states in 2008?
Your answer should be very brief. 3.61e+08. What is the difference between the Aid flow (current US$) of East Asia (developing only) in 2003 and the Aid flow (current US$) of Antigua and Barbuda in 2008?
Keep it short and to the point. 3.73e+08. What is the difference between the Aid flow (current US$) of Latin America(all income levels) in 2003 and the Aid flow (current US$) of Pacific island small states in 2008?
Ensure brevity in your answer.  2.01e+08. What is the difference between the Aid flow (current US$) of Latin America(all income levels) in 2003 and the Aid flow (current US$) of Antigua and Barbuda in 2008?
Offer a terse response. 2.13e+08. What is the difference between the Aid flow (current US$) in Pacific island small states in 2003 and the Aid flow (current US$) in Antigua and Barbuda in 2008?
Keep it short and to the point. 4.80e+06. What is the difference between the Aid flow (current US$) in East Asia (developing only) in 2004 and the Aid flow (current US$) in Latin America(all income levels) in 2005?
Your response must be concise. 1.45e+08. What is the difference between the Aid flow (current US$) in East Asia (developing only) in 2004 and the Aid flow (current US$) in Pacific island small states in 2005?
Give a very brief answer. 3.91e+08. What is the difference between the Aid flow (current US$) in East Asia (developing only) in 2004 and the Aid flow (current US$) in Antigua and Barbuda in 2005?
Provide a short and direct response. 3.95e+08. What is the difference between the Aid flow (current US$) of Latin America(all income levels) in 2004 and the Aid flow (current US$) of Pacific island small states in 2005?
Ensure brevity in your answer.  3.39e+08. What is the difference between the Aid flow (current US$) of Latin America(all income levels) in 2004 and the Aid flow (current US$) of Antigua and Barbuda in 2005?
Your response must be concise. 3.43e+08. What is the difference between the Aid flow (current US$) in Pacific island small states in 2004 and the Aid flow (current US$) in Antigua and Barbuda in 2005?
Provide a short and direct response. 6.99e+06. What is the difference between the Aid flow (current US$) in East Asia (developing only) in 2004 and the Aid flow (current US$) in Latin America(all income levels) in 2007?
Your answer should be compact. 3.55e+07. What is the difference between the Aid flow (current US$) of East Asia (developing only) in 2004 and the Aid flow (current US$) of Pacific island small states in 2007?
Your answer should be compact. 3.83e+08. What is the difference between the Aid flow (current US$) in East Asia (developing only) in 2004 and the Aid flow (current US$) in Antigua and Barbuda in 2007?
Offer a terse response. 3.95e+08. What is the difference between the Aid flow (current US$) of Latin America(all income levels) in 2004 and the Aid flow (current US$) of Pacific island small states in 2007?
Provide a succinct answer. 3.32e+08. What is the difference between the Aid flow (current US$) in Latin America(all income levels) in 2004 and the Aid flow (current US$) in Antigua and Barbuda in 2007?
Offer a terse response. 3.43e+08. What is the difference between the Aid flow (current US$) of East Asia (developing only) in 2004 and the Aid flow (current US$) of Latin America(all income levels) in 2008?
Ensure brevity in your answer.  1.82e+08. What is the difference between the Aid flow (current US$) of East Asia (developing only) in 2004 and the Aid flow (current US$) of Pacific island small states in 2008?
Provide a succinct answer. 3.83e+08. What is the difference between the Aid flow (current US$) of East Asia (developing only) in 2004 and the Aid flow (current US$) of Antigua and Barbuda in 2008?
Give a very brief answer. 3.95e+08. What is the difference between the Aid flow (current US$) of Latin America(all income levels) in 2004 and the Aid flow (current US$) of Pacific island small states in 2008?
Your answer should be compact. 3.31e+08. What is the difference between the Aid flow (current US$) in Latin America(all income levels) in 2004 and the Aid flow (current US$) in Antigua and Barbuda in 2008?
Provide a succinct answer. 3.43e+08. What is the difference between the Aid flow (current US$) of Pacific island small states in 2004 and the Aid flow (current US$) of Antigua and Barbuda in 2008?
Keep it short and to the point. 7.01e+06. What is the difference between the Aid flow (current US$) of East Asia (developing only) in 2005 and the Aid flow (current US$) of Latin America(all income levels) in 2007?
Give a very brief answer. 8.00e+07. What is the difference between the Aid flow (current US$) of East Asia (developing only) in 2005 and the Aid flow (current US$) of Pacific island small states in 2007?
Give a very brief answer. 4.28e+08. What is the difference between the Aid flow (current US$) in East Asia (developing only) in 2005 and the Aid flow (current US$) in Antigua and Barbuda in 2007?
Provide a succinct answer. 4.40e+08. What is the difference between the Aid flow (current US$) of Latin America(all income levels) in 2005 and the Aid flow (current US$) of Pacific island small states in 2007?
Your answer should be very brief. 2.38e+08. What is the difference between the Aid flow (current US$) of Latin America(all income levels) in 2005 and the Aid flow (current US$) of Antigua and Barbuda in 2007?
Provide a short and direct response. 2.50e+08. What is the difference between the Aid flow (current US$) in Pacific island small states in 2005 and the Aid flow (current US$) in Antigua and Barbuda in 2007?
Offer a terse response. 4.43e+06. What is the difference between the Aid flow (current US$) in East Asia (developing only) in 2005 and the Aid flow (current US$) in Latin America(all income levels) in 2008?
Offer a very short reply. 2.26e+08. What is the difference between the Aid flow (current US$) of East Asia (developing only) in 2005 and the Aid flow (current US$) of Pacific island small states in 2008?
Your answer should be compact. 4.28e+08. What is the difference between the Aid flow (current US$) in East Asia (developing only) in 2005 and the Aid flow (current US$) in Antigua and Barbuda in 2008?
Your answer should be very brief. 4.40e+08. What is the difference between the Aid flow (current US$) of Latin America(all income levels) in 2005 and the Aid flow (current US$) of Pacific island small states in 2008?
Give a very brief answer. 2.38e+08. What is the difference between the Aid flow (current US$) of Latin America(all income levels) in 2005 and the Aid flow (current US$) of Antigua and Barbuda in 2008?
Keep it short and to the point. 2.50e+08. What is the difference between the Aid flow (current US$) in Pacific island small states in 2005 and the Aid flow (current US$) in Antigua and Barbuda in 2008?
Give a very brief answer. 4.44e+06. What is the difference between the Aid flow (current US$) in East Asia (developing only) in 2007 and the Aid flow (current US$) in Latin America(all income levels) in 2008?
Your response must be concise. 2.18e+08. What is the difference between the Aid flow (current US$) of East Asia (developing only) in 2007 and the Aid flow (current US$) of Pacific island small states in 2008?
Offer a very short reply. 4.20e+08. What is the difference between the Aid flow (current US$) of East Asia (developing only) in 2007 and the Aid flow (current US$) of Antigua and Barbuda in 2008?
Keep it short and to the point. 4.32e+08. What is the difference between the Aid flow (current US$) in Latin America(all income levels) in 2007 and the Aid flow (current US$) in Pacific island small states in 2008?
Keep it short and to the point. 3.48e+08. What is the difference between the Aid flow (current US$) in Latin America(all income levels) in 2007 and the Aid flow (current US$) in Antigua and Barbuda in 2008?
Your answer should be very brief. 3.60e+08. What is the difference between the Aid flow (current US$) in Pacific island small states in 2007 and the Aid flow (current US$) in Antigua and Barbuda in 2008?
Keep it short and to the point. 1.16e+07. What is the average Aid flow (current US$) in East Asia (developing only) per year?
Your answer should be very brief. 3.85e+08. What is the average Aid flow (current US$) of Latin America(all income levels) per year?
Keep it short and to the point. 2.22e+08. What is the average Aid flow (current US$) in Pacific island small states per year?
Make the answer very short. 7.74e+06. What is the average Aid flow (current US$) in Antigua and Barbuda per year?
Your response must be concise. 8.75e+04. In the year 2000, what is the difference between the Aid flow (current US$) in East Asia (developing only) and Aid flow (current US$) in Latin America(all income levels)?
Give a very brief answer. 1.09e+08. In the year 2000, what is the difference between the Aid flow (current US$) in East Asia (developing only) and Aid flow (current US$) in Pacific island small states?
Give a very brief answer. 2.09e+08. In the year 2000, what is the difference between the Aid flow (current US$) of East Asia (developing only) and Aid flow (current US$) of Antigua and Barbuda?
Offer a terse response. 2.18e+08. In the year 2000, what is the difference between the Aid flow (current US$) of Latin America(all income levels) and Aid flow (current US$) of Pacific island small states?
Your answer should be very brief. 1.00e+08. In the year 2000, what is the difference between the Aid flow (current US$) in Latin America(all income levels) and Aid flow (current US$) in Antigua and Barbuda?
Ensure brevity in your answer.  1.09e+08. In the year 2000, what is the difference between the Aid flow (current US$) in Pacific island small states and Aid flow (current US$) in Antigua and Barbuda?
Your answer should be very brief. 9.28e+06. In the year 2001, what is the difference between the Aid flow (current US$) in East Asia (developing only) and Aid flow (current US$) in Latin America(all income levels)?
Offer a very short reply. 1.03e+08. In the year 2001, what is the difference between the Aid flow (current US$) in East Asia (developing only) and Aid flow (current US$) in Pacific island small states?
Offer a terse response. 2.09e+08. In the year 2001, what is the difference between the Aid flow (current US$) of East Asia (developing only) and Aid flow (current US$) of Antigua and Barbuda?
Provide a short and direct response. 2.14e+08. In the year 2001, what is the difference between the Aid flow (current US$) of Latin America(all income levels) and Aid flow (current US$) of Pacific island small states?
Your answer should be compact. 1.06e+08. In the year 2001, what is the difference between the Aid flow (current US$) of Latin America(all income levels) and Aid flow (current US$) of Antigua and Barbuda?
Your response must be concise. 1.11e+08. In the year 2001, what is the difference between the Aid flow (current US$) in Pacific island small states and Aid flow (current US$) in Antigua and Barbuda?
Provide a succinct answer. 5.57e+06. In the year 2002, what is the difference between the Aid flow (current US$) of East Asia (developing only) and Aid flow (current US$) of Latin America(all income levels)?
Ensure brevity in your answer.  1.43e+08. In the year 2002, what is the difference between the Aid flow (current US$) in East Asia (developing only) and Aid flow (current US$) in Pacific island small states?
Give a very brief answer. 3.11e+08. In the year 2002, what is the difference between the Aid flow (current US$) in East Asia (developing only) and Aid flow (current US$) in Antigua and Barbuda?
Offer a terse response. 3.18e+08. In the year 2002, what is the difference between the Aid flow (current US$) in Latin America(all income levels) and Aid flow (current US$) in Pacific island small states?
Your answer should be very brief. 1.68e+08. In the year 2002, what is the difference between the Aid flow (current US$) in Latin America(all income levels) and Aid flow (current US$) in Antigua and Barbuda?
Your answer should be very brief. 1.75e+08. In the year 2002, what is the difference between the Aid flow (current US$) of Pacific island small states and Aid flow (current US$) of Antigua and Barbuda?
Provide a succinct answer. 6.53e+06. In the year 2003, what is the difference between the Aid flow (current US$) in East Asia (developing only) and Aid flow (current US$) in Latin America(all income levels)?
Make the answer very short. 1.60e+08. In the year 2003, what is the difference between the Aid flow (current US$) in East Asia (developing only) and Aid flow (current US$) in Pacific island small states?
Give a very brief answer. 3.68e+08. In the year 2003, what is the difference between the Aid flow (current US$) of East Asia (developing only) and Aid flow (current US$) of Antigua and Barbuda?
Keep it short and to the point. 3.73e+08. In the year 2003, what is the difference between the Aid flow (current US$) of Latin America(all income levels) and Aid flow (current US$) of Pacific island small states?
Your answer should be very brief. 2.08e+08. In the year 2003, what is the difference between the Aid flow (current US$) of Latin America(all income levels) and Aid flow (current US$) of Antigua and Barbuda?
Give a very brief answer. 2.13e+08. In the year 2003, what is the difference between the Aid flow (current US$) of Pacific island small states and Aid flow (current US$) of Antigua and Barbuda?
Provide a succinct answer. 4.80e+06. In the year 2004, what is the difference between the Aid flow (current US$) of East Asia (developing only) and Aid flow (current US$) of Latin America(all income levels)?
Your answer should be compact. 5.16e+07. In the year 2004, what is the difference between the Aid flow (current US$) in East Asia (developing only) and Aid flow (current US$) in Pacific island small states?
Give a very brief answer. 3.88e+08. In the year 2004, what is the difference between the Aid flow (current US$) of East Asia (developing only) and Aid flow (current US$) of Antigua and Barbuda?
Offer a very short reply. 3.95e+08. In the year 2004, what is the difference between the Aid flow (current US$) of Latin America(all income levels) and Aid flow (current US$) of Pacific island small states?
Offer a terse response. 3.36e+08. In the year 2004, what is the difference between the Aid flow (current US$) in Latin America(all income levels) and Aid flow (current US$) in Antigua and Barbuda?
Provide a short and direct response. 3.43e+08. In the year 2004, what is the difference between the Aid flow (current US$) of Pacific island small states and Aid flow (current US$) of Antigua and Barbuda?
Your response must be concise. 7.00e+06. In the year 2005, what is the difference between the Aid flow (current US$) in East Asia (developing only) and Aid flow (current US$) in Latin America(all income levels)?
Provide a short and direct response. 1.89e+08. In the year 2005, what is the difference between the Aid flow (current US$) of East Asia (developing only) and Aid flow (current US$) of Pacific island small states?
Provide a short and direct response. 4.35e+08. In the year 2005, what is the difference between the Aid flow (current US$) in East Asia (developing only) and Aid flow (current US$) in Antigua and Barbuda?
Make the answer very short. 4.40e+08. In the year 2005, what is the difference between the Aid flow (current US$) in Latin America(all income levels) and Aid flow (current US$) in Pacific island small states?
Ensure brevity in your answer.  2.46e+08. In the year 2005, what is the difference between the Aid flow (current US$) of Latin America(all income levels) and Aid flow (current US$) of Antigua and Barbuda?
Your answer should be compact. 2.50e+08. In the year 2005, what is the difference between the Aid flow (current US$) of Pacific island small states and Aid flow (current US$) of Antigua and Barbuda?
Provide a succinct answer. 4.42e+06. In the year 2007, what is the difference between the Aid flow (current US$) of East Asia (developing only) and Aid flow (current US$) of Latin America(all income levels)?
Ensure brevity in your answer.  7.21e+07. In the year 2007, what is the difference between the Aid flow (current US$) of East Asia (developing only) and Aid flow (current US$) of Pacific island small states?
Provide a succinct answer. 4.20e+08. In the year 2007, what is the difference between the Aid flow (current US$) in East Asia (developing only) and Aid flow (current US$) in Antigua and Barbuda?
Give a very brief answer. 4.32e+08. In the year 2007, what is the difference between the Aid flow (current US$) in Latin America(all income levels) and Aid flow (current US$) in Pacific island small states?
Your answer should be very brief. 3.48e+08. In the year 2007, what is the difference between the Aid flow (current US$) in Latin America(all income levels) and Aid flow (current US$) in Antigua and Barbuda?
Your response must be concise. 3.60e+08. In the year 2007, what is the difference between the Aid flow (current US$) in Pacific island small states and Aid flow (current US$) in Antigua and Barbuda?
Offer a terse response. 1.16e+07. In the year 2008, what is the difference between the Aid flow (current US$) of East Asia (developing only) and Aid flow (current US$) of Latin America(all income levels)?
Make the answer very short. 4.79e+08. In the year 2008, what is the difference between the Aid flow (current US$) of East Asia (developing only) and Aid flow (current US$) of Pacific island small states?
Ensure brevity in your answer.  6.80e+08. In the year 2008, what is the difference between the Aid flow (current US$) of East Asia (developing only) and Aid flow (current US$) of Antigua and Barbuda?
Provide a succinct answer. 6.92e+08. In the year 2008, what is the difference between the Aid flow (current US$) in Latin America(all income levels) and Aid flow (current US$) in Pacific island small states?
Your answer should be compact. 2.01e+08. In the year 2008, what is the difference between the Aid flow (current US$) in Latin America(all income levels) and Aid flow (current US$) in Antigua and Barbuda?
Give a very brief answer. 2.13e+08. In the year 2008, what is the difference between the Aid flow (current US$) in Pacific island small states and Aid flow (current US$) in Antigua and Barbuda?
Your answer should be very brief. 1.20e+07. What is the ratio of the Aid flow (current US$) in East Asia (developing only) in 2000 to that in 2001?
Provide a succinct answer. 1.02. What is the ratio of the Aid flow (current US$) of Latin America(all income levels) in 2000 to that in 2001?
Your response must be concise. 0.98. What is the ratio of the Aid flow (current US$) in Pacific island small states in 2000 to that in 2001?
Your answer should be compact. 1.51. What is the ratio of the Aid flow (current US$) of Antigua and Barbuda in 2000 to that in 2001?
Offer a terse response. 0.02. What is the ratio of the Aid flow (current US$) of East Asia (developing only) in 2000 to that in 2002?
Offer a very short reply. 0.69. What is the ratio of the Aid flow (current US$) of Latin America(all income levels) in 2000 to that in 2002?
Your answer should be compact. 0.63. What is the ratio of the Aid flow (current US$) in Pacific island small states in 2000 to that in 2002?
Your answer should be compact. 1.42. What is the ratio of the Aid flow (current US$) of East Asia (developing only) in 2000 to that in 2003?
Ensure brevity in your answer.  0.58. What is the ratio of the Aid flow (current US$) in Latin America(all income levels) in 2000 to that in 2003?
Your response must be concise. 0.51. What is the ratio of the Aid flow (current US$) of Pacific island small states in 2000 to that in 2003?
Your answer should be compact. 1.93. What is the ratio of the Aid flow (current US$) of East Asia (developing only) in 2000 to that in 2004?
Provide a succinct answer. 0.55. What is the ratio of the Aid flow (current US$) in Latin America(all income levels) in 2000 to that in 2004?
Your answer should be very brief. 0.32. What is the ratio of the Aid flow (current US$) in Pacific island small states in 2000 to that in 2004?
Ensure brevity in your answer.  1.32. What is the ratio of the Aid flow (current US$) in East Asia (developing only) in 2000 to that in 2005?
Keep it short and to the point. 0.5. What is the ratio of the Aid flow (current US$) of Latin America(all income levels) in 2000 to that in 2005?
Provide a succinct answer. 0.44. What is the ratio of the Aid flow (current US$) in Pacific island small states in 2000 to that in 2005?
Your answer should be very brief. 2.09. What is the ratio of the Aid flow (current US$) in Antigua and Barbuda in 2000 to that in 2005?
Keep it short and to the point. 0.33. What is the ratio of the Aid flow (current US$) of East Asia (developing only) in 2000 to that in 2007?
Your answer should be compact. 0.51. What is the ratio of the Aid flow (current US$) of Latin America(all income levels) in 2000 to that in 2007?
Your answer should be compact. 0.3. What is the ratio of the Aid flow (current US$) in Pacific island small states in 2000 to that in 2007?
Your response must be concise. 0.8. What is the ratio of the Aid flow (current US$) of Antigua and Barbuda in 2000 to that in 2007?
Your answer should be compact. 0.5. What is the ratio of the Aid flow (current US$) in East Asia (developing only) in 2000 to that in 2008?
Keep it short and to the point. 0.32. What is the ratio of the Aid flow (current US$) of Latin America(all income levels) in 2000 to that in 2008?
Your answer should be very brief. 0.51. What is the ratio of the Aid flow (current US$) in Pacific island small states in 2000 to that in 2008?
Provide a succinct answer. 0.77. What is the ratio of the Aid flow (current US$) in Antigua and Barbuda in 2000 to that in 2008?
Offer a terse response. 1. What is the ratio of the Aid flow (current US$) in East Asia (developing only) in 2001 to that in 2002?
Ensure brevity in your answer.  0.68. What is the ratio of the Aid flow (current US$) in Latin America(all income levels) in 2001 to that in 2002?
Your answer should be very brief. 0.64. What is the ratio of the Aid flow (current US$) in Pacific island small states in 2001 to that in 2002?
Your response must be concise. 0.94. What is the ratio of the Aid flow (current US$) in East Asia (developing only) in 2001 to that in 2003?
Ensure brevity in your answer.  0.58. What is the ratio of the Aid flow (current US$) in Latin America(all income levels) in 2001 to that in 2003?
Give a very brief answer. 0.52. What is the ratio of the Aid flow (current US$) in Pacific island small states in 2001 to that in 2003?
Your answer should be compact. 1.28. What is the ratio of the Aid flow (current US$) in Antigua and Barbuda in 2001 to that in 2003?
Your answer should be compact. 58. What is the ratio of the Aid flow (current US$) of East Asia (developing only) in 2001 to that in 2004?
Make the answer very short. 0.54. What is the ratio of the Aid flow (current US$) in Latin America(all income levels) in 2001 to that in 2004?
Offer a very short reply. 0.33. What is the ratio of the Aid flow (current US$) in Pacific island small states in 2001 to that in 2004?
Provide a succinct answer. 0.88. What is the ratio of the Aid flow (current US$) in Antigua and Barbuda in 2001 to that in 2004?
Your answer should be compact. 29. What is the ratio of the Aid flow (current US$) in East Asia (developing only) in 2001 to that in 2005?
Ensure brevity in your answer.  0.49. What is the ratio of the Aid flow (current US$) of Latin America(all income levels) in 2001 to that in 2005?
Keep it short and to the point. 0.45. What is the ratio of the Aid flow (current US$) of Pacific island small states in 2001 to that in 2005?
Provide a short and direct response. 1.38. What is the ratio of the Aid flow (current US$) in Antigua and Barbuda in 2001 to that in 2005?
Provide a succinct answer. 19.33. What is the ratio of the Aid flow (current US$) of East Asia (developing only) in 2001 to that in 2007?
Keep it short and to the point. 0.5. What is the ratio of the Aid flow (current US$) in Latin America(all income levels) in 2001 to that in 2007?
Provide a short and direct response. 0.31. What is the ratio of the Aid flow (current US$) of Pacific island small states in 2001 to that in 2007?
Your response must be concise. 0.53. What is the ratio of the Aid flow (current US$) in East Asia (developing only) in 2001 to that in 2008?
Provide a short and direct response. 0.31. What is the ratio of the Aid flow (current US$) of Latin America(all income levels) in 2001 to that in 2008?
Offer a very short reply. 0.52. What is the ratio of the Aid flow (current US$) of Pacific island small states in 2001 to that in 2008?
Offer a terse response. 0.51. What is the ratio of the Aid flow (current US$) of East Asia (developing only) in 2002 to that in 2003?
Your response must be concise. 0.85. What is the ratio of the Aid flow (current US$) of Latin America(all income levels) in 2002 to that in 2003?
Your answer should be very brief. 0.82. What is the ratio of the Aid flow (current US$) in Pacific island small states in 2002 to that in 2003?
Provide a succinct answer. 1.36. What is the ratio of the Aid flow (current US$) of East Asia (developing only) in 2002 to that in 2004?
Your answer should be very brief. 0.8. What is the ratio of the Aid flow (current US$) of Latin America(all income levels) in 2002 to that in 2004?
Make the answer very short. 0.51. What is the ratio of the Aid flow (current US$) of Pacific island small states in 2002 to that in 2004?
Provide a succinct answer. 0.93. What is the ratio of the Aid flow (current US$) of East Asia (developing only) in 2002 to that in 2005?
Provide a short and direct response. 0.72. What is the ratio of the Aid flow (current US$) in Latin America(all income levels) in 2002 to that in 2005?
Make the answer very short. 0.7. What is the ratio of the Aid flow (current US$) of Pacific island small states in 2002 to that in 2005?
Your response must be concise. 1.47. What is the ratio of the Aid flow (current US$) in Antigua and Barbuda in 2002 to that in 2005?
Keep it short and to the point. 0.67. What is the ratio of the Aid flow (current US$) in East Asia (developing only) in 2002 to that in 2007?
Keep it short and to the point. 0.74. What is the ratio of the Aid flow (current US$) of Latin America(all income levels) in 2002 to that in 2007?
Your response must be concise. 0.49. What is the ratio of the Aid flow (current US$) in Pacific island small states in 2002 to that in 2007?
Make the answer very short. 0.56. What is the ratio of the Aid flow (current US$) in East Asia (developing only) in 2002 to that in 2008?
Your answer should be compact. 0.46. What is the ratio of the Aid flow (current US$) in Latin America(all income levels) in 2002 to that in 2008?
Keep it short and to the point. 0.82. What is the ratio of the Aid flow (current US$) in Pacific island small states in 2002 to that in 2008?
Your answer should be compact. 0.54. What is the ratio of the Aid flow (current US$) of East Asia (developing only) in 2003 to that in 2004?
Provide a succinct answer. 0.94. What is the ratio of the Aid flow (current US$) in Latin America(all income levels) in 2003 to that in 2004?
Your answer should be very brief. 0.62. What is the ratio of the Aid flow (current US$) of Pacific island small states in 2003 to that in 2004?
Provide a short and direct response. 0.69. What is the ratio of the Aid flow (current US$) in Antigua and Barbuda in 2003 to that in 2004?
Your answer should be compact. 0.5. What is the ratio of the Aid flow (current US$) of East Asia (developing only) in 2003 to that in 2005?
Your response must be concise. 0.85. What is the ratio of the Aid flow (current US$) in Latin America(all income levels) in 2003 to that in 2005?
Make the answer very short. 0.85. What is the ratio of the Aid flow (current US$) of Pacific island small states in 2003 to that in 2005?
Make the answer very short. 1.08. What is the ratio of the Aid flow (current US$) of East Asia (developing only) in 2003 to that in 2007?
Your answer should be very brief. 0.86. What is the ratio of the Aid flow (current US$) of Latin America(all income levels) in 2003 to that in 2007?
Your answer should be very brief. 0.59. What is the ratio of the Aid flow (current US$) in Pacific island small states in 2003 to that in 2007?
Ensure brevity in your answer.  0.41. What is the ratio of the Aid flow (current US$) of Antigua and Barbuda in 2003 to that in 2007?
Offer a very short reply. 0.5. What is the ratio of the Aid flow (current US$) in East Asia (developing only) in 2003 to that in 2008?
Your response must be concise. 0.54. What is the ratio of the Aid flow (current US$) of Pacific island small states in 2003 to that in 2008?
Your answer should be very brief. 0.4. What is the ratio of the Aid flow (current US$) in East Asia (developing only) in 2004 to that in 2005?
Offer a very short reply. 0.9. What is the ratio of the Aid flow (current US$) in Latin America(all income levels) in 2004 to that in 2005?
Give a very brief answer. 1.37. What is the ratio of the Aid flow (current US$) of Pacific island small states in 2004 to that in 2005?
Ensure brevity in your answer.  1.58. What is the ratio of the Aid flow (current US$) of East Asia (developing only) in 2004 to that in 2007?
Your response must be concise. 0.92. What is the ratio of the Aid flow (current US$) of Latin America(all income levels) in 2004 to that in 2007?
Your answer should be very brief. 0.96. What is the ratio of the Aid flow (current US$) in Pacific island small states in 2004 to that in 2007?
Offer a very short reply. 0.6. What is the ratio of the Aid flow (current US$) of East Asia (developing only) in 2004 to that in 2008?
Offer a terse response. 0.57. What is the ratio of the Aid flow (current US$) in Latin America(all income levels) in 2004 to that in 2008?
Keep it short and to the point. 1.61. What is the ratio of the Aid flow (current US$) in Pacific island small states in 2004 to that in 2008?
Provide a succinct answer. 0.58. What is the ratio of the Aid flow (current US$) in Antigua and Barbuda in 2004 to that in 2008?
Make the answer very short. 2. What is the ratio of the Aid flow (current US$) of East Asia (developing only) in 2005 to that in 2007?
Ensure brevity in your answer.  1.02. What is the ratio of the Aid flow (current US$) in Latin America(all income levels) in 2005 to that in 2007?
Offer a very short reply. 0.7. What is the ratio of the Aid flow (current US$) in Pacific island small states in 2005 to that in 2007?
Provide a short and direct response. 0.38. What is the ratio of the Aid flow (current US$) in Antigua and Barbuda in 2005 to that in 2007?
Your answer should be compact. 1.5. What is the ratio of the Aid flow (current US$) of East Asia (developing only) in 2005 to that in 2008?
Your answer should be very brief. 0.64. What is the ratio of the Aid flow (current US$) of Latin America(all income levels) in 2005 to that in 2008?
Provide a short and direct response. 1.17. What is the ratio of the Aid flow (current US$) of Pacific island small states in 2005 to that in 2008?
Offer a very short reply. 0.37. What is the ratio of the Aid flow (current US$) in Antigua and Barbuda in 2005 to that in 2008?
Keep it short and to the point. 3. What is the ratio of the Aid flow (current US$) in East Asia (developing only) in 2007 to that in 2008?
Keep it short and to the point. 0.62. What is the ratio of the Aid flow (current US$) in Latin America(all income levels) in 2007 to that in 2008?
Keep it short and to the point. 1.69. What is the ratio of the Aid flow (current US$) in Pacific island small states in 2007 to that in 2008?
Ensure brevity in your answer.  0.97. What is the ratio of the Aid flow (current US$) in Antigua and Barbuda in 2007 to that in 2008?
Ensure brevity in your answer.  2. What is the difference between the highest and the second highest Aid flow (current US$) in East Asia (developing only)?
Offer a very short reply. 2.52e+08. What is the difference between the highest and the second highest Aid flow (current US$) of Latin America(all income levels)?
Offer a terse response. 1.62e+07. What is the difference between the highest and the lowest Aid flow (current US$) in East Asia (developing only)?
Ensure brevity in your answer.  4.77e+08. What is the difference between the highest and the lowest Aid flow (current US$) in Latin America(all income levels)?
Your response must be concise. 2.50e+08. What is the difference between the highest and the lowest Aid flow (current US$) of Pacific island small states?
Your answer should be compact. 7.58e+06. What is the difference between the highest and the lowest Aid flow (current US$) of Antigua and Barbuda?
Provide a short and direct response. 5.70e+05. 